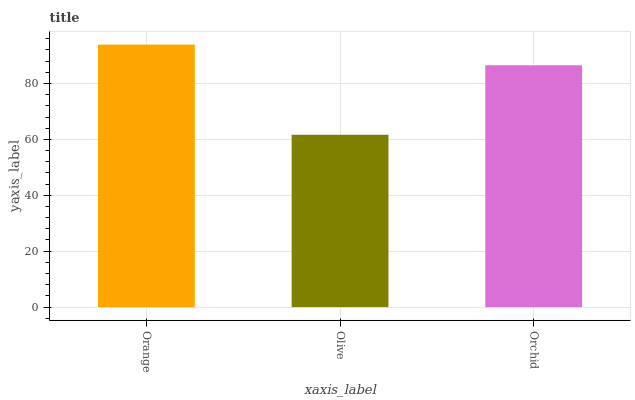Is Orchid the minimum?
Answer yes or no. No. Is Orchid the maximum?
Answer yes or no. No. Is Orchid greater than Olive?
Answer yes or no. Yes. Is Olive less than Orchid?
Answer yes or no. Yes. Is Olive greater than Orchid?
Answer yes or no. No. Is Orchid less than Olive?
Answer yes or no. No. Is Orchid the high median?
Answer yes or no. Yes. Is Orchid the low median?
Answer yes or no. Yes. Is Orange the high median?
Answer yes or no. No. Is Orange the low median?
Answer yes or no. No. 